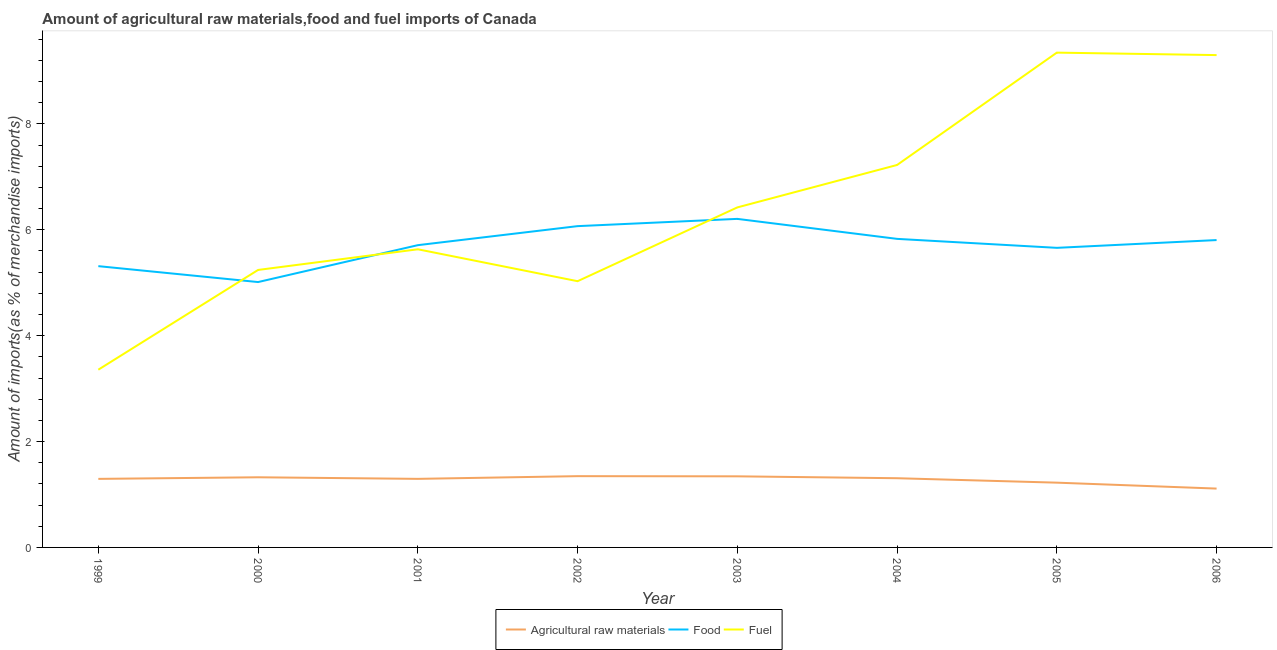How many different coloured lines are there?
Your answer should be very brief. 3. Does the line corresponding to percentage of food imports intersect with the line corresponding to percentage of raw materials imports?
Offer a terse response. No. What is the percentage of fuel imports in 2001?
Your response must be concise. 5.63. Across all years, what is the maximum percentage of fuel imports?
Ensure brevity in your answer.  9.35. Across all years, what is the minimum percentage of fuel imports?
Your answer should be compact. 3.36. In which year was the percentage of raw materials imports maximum?
Your response must be concise. 2002. In which year was the percentage of fuel imports minimum?
Your answer should be compact. 1999. What is the total percentage of food imports in the graph?
Your answer should be compact. 45.6. What is the difference between the percentage of raw materials imports in 2001 and that in 2002?
Offer a terse response. -0.05. What is the difference between the percentage of fuel imports in 2006 and the percentage of raw materials imports in 2003?
Offer a terse response. 7.96. What is the average percentage of food imports per year?
Keep it short and to the point. 5.7. In the year 1999, what is the difference between the percentage of food imports and percentage of fuel imports?
Keep it short and to the point. 1.96. In how many years, is the percentage of food imports greater than 7.6 %?
Your answer should be compact. 0. What is the ratio of the percentage of fuel imports in 2000 to that in 2005?
Keep it short and to the point. 0.56. Is the percentage of raw materials imports in 2001 less than that in 2005?
Ensure brevity in your answer.  No. What is the difference between the highest and the second highest percentage of raw materials imports?
Ensure brevity in your answer.  0. What is the difference between the highest and the lowest percentage of raw materials imports?
Offer a terse response. 0.23. Is it the case that in every year, the sum of the percentage of raw materials imports and percentage of food imports is greater than the percentage of fuel imports?
Your answer should be compact. No. Does the percentage of food imports monotonically increase over the years?
Your answer should be very brief. No. Is the percentage of fuel imports strictly greater than the percentage of raw materials imports over the years?
Your response must be concise. Yes. Is the percentage of raw materials imports strictly less than the percentage of food imports over the years?
Your response must be concise. Yes. How many lines are there?
Give a very brief answer. 3. How many years are there in the graph?
Your response must be concise. 8. Does the graph contain any zero values?
Keep it short and to the point. No. Does the graph contain grids?
Give a very brief answer. No. Where does the legend appear in the graph?
Offer a terse response. Bottom center. How many legend labels are there?
Provide a short and direct response. 3. What is the title of the graph?
Make the answer very short. Amount of agricultural raw materials,food and fuel imports of Canada. What is the label or title of the X-axis?
Give a very brief answer. Year. What is the label or title of the Y-axis?
Provide a short and direct response. Amount of imports(as % of merchandise imports). What is the Amount of imports(as % of merchandise imports) of Agricultural raw materials in 1999?
Keep it short and to the point. 1.29. What is the Amount of imports(as % of merchandise imports) of Food in 1999?
Your answer should be very brief. 5.31. What is the Amount of imports(as % of merchandise imports) in Fuel in 1999?
Provide a succinct answer. 3.36. What is the Amount of imports(as % of merchandise imports) of Agricultural raw materials in 2000?
Your answer should be very brief. 1.33. What is the Amount of imports(as % of merchandise imports) of Food in 2000?
Give a very brief answer. 5.01. What is the Amount of imports(as % of merchandise imports) of Fuel in 2000?
Your answer should be compact. 5.24. What is the Amount of imports(as % of merchandise imports) of Agricultural raw materials in 2001?
Offer a terse response. 1.3. What is the Amount of imports(as % of merchandise imports) of Food in 2001?
Your response must be concise. 5.71. What is the Amount of imports(as % of merchandise imports) of Fuel in 2001?
Keep it short and to the point. 5.63. What is the Amount of imports(as % of merchandise imports) of Agricultural raw materials in 2002?
Your answer should be very brief. 1.35. What is the Amount of imports(as % of merchandise imports) of Food in 2002?
Ensure brevity in your answer.  6.07. What is the Amount of imports(as % of merchandise imports) in Fuel in 2002?
Keep it short and to the point. 5.03. What is the Amount of imports(as % of merchandise imports) of Agricultural raw materials in 2003?
Keep it short and to the point. 1.34. What is the Amount of imports(as % of merchandise imports) in Food in 2003?
Offer a terse response. 6.21. What is the Amount of imports(as % of merchandise imports) of Fuel in 2003?
Your response must be concise. 6.42. What is the Amount of imports(as % of merchandise imports) of Agricultural raw materials in 2004?
Give a very brief answer. 1.31. What is the Amount of imports(as % of merchandise imports) in Food in 2004?
Your response must be concise. 5.83. What is the Amount of imports(as % of merchandise imports) of Fuel in 2004?
Your answer should be very brief. 7.22. What is the Amount of imports(as % of merchandise imports) of Agricultural raw materials in 2005?
Give a very brief answer. 1.22. What is the Amount of imports(as % of merchandise imports) in Food in 2005?
Ensure brevity in your answer.  5.66. What is the Amount of imports(as % of merchandise imports) of Fuel in 2005?
Offer a very short reply. 9.35. What is the Amount of imports(as % of merchandise imports) of Agricultural raw materials in 2006?
Your answer should be compact. 1.11. What is the Amount of imports(as % of merchandise imports) of Food in 2006?
Offer a very short reply. 5.81. What is the Amount of imports(as % of merchandise imports) in Fuel in 2006?
Provide a short and direct response. 9.3. Across all years, what is the maximum Amount of imports(as % of merchandise imports) in Agricultural raw materials?
Your response must be concise. 1.35. Across all years, what is the maximum Amount of imports(as % of merchandise imports) in Food?
Offer a very short reply. 6.21. Across all years, what is the maximum Amount of imports(as % of merchandise imports) in Fuel?
Make the answer very short. 9.35. Across all years, what is the minimum Amount of imports(as % of merchandise imports) in Agricultural raw materials?
Your response must be concise. 1.11. Across all years, what is the minimum Amount of imports(as % of merchandise imports) in Food?
Give a very brief answer. 5.01. Across all years, what is the minimum Amount of imports(as % of merchandise imports) in Fuel?
Make the answer very short. 3.36. What is the total Amount of imports(as % of merchandise imports) in Agricultural raw materials in the graph?
Offer a terse response. 10.25. What is the total Amount of imports(as % of merchandise imports) in Food in the graph?
Your response must be concise. 45.6. What is the total Amount of imports(as % of merchandise imports) in Fuel in the graph?
Provide a short and direct response. 51.55. What is the difference between the Amount of imports(as % of merchandise imports) in Agricultural raw materials in 1999 and that in 2000?
Offer a very short reply. -0.03. What is the difference between the Amount of imports(as % of merchandise imports) in Food in 1999 and that in 2000?
Provide a short and direct response. 0.3. What is the difference between the Amount of imports(as % of merchandise imports) in Fuel in 1999 and that in 2000?
Make the answer very short. -1.88. What is the difference between the Amount of imports(as % of merchandise imports) of Agricultural raw materials in 1999 and that in 2001?
Give a very brief answer. -0. What is the difference between the Amount of imports(as % of merchandise imports) of Food in 1999 and that in 2001?
Make the answer very short. -0.4. What is the difference between the Amount of imports(as % of merchandise imports) of Fuel in 1999 and that in 2001?
Offer a terse response. -2.27. What is the difference between the Amount of imports(as % of merchandise imports) in Agricultural raw materials in 1999 and that in 2002?
Provide a succinct answer. -0.05. What is the difference between the Amount of imports(as % of merchandise imports) of Food in 1999 and that in 2002?
Keep it short and to the point. -0.76. What is the difference between the Amount of imports(as % of merchandise imports) of Fuel in 1999 and that in 2002?
Offer a terse response. -1.67. What is the difference between the Amount of imports(as % of merchandise imports) in Agricultural raw materials in 1999 and that in 2003?
Offer a very short reply. -0.05. What is the difference between the Amount of imports(as % of merchandise imports) of Food in 1999 and that in 2003?
Ensure brevity in your answer.  -0.89. What is the difference between the Amount of imports(as % of merchandise imports) in Fuel in 1999 and that in 2003?
Keep it short and to the point. -3.07. What is the difference between the Amount of imports(as % of merchandise imports) in Agricultural raw materials in 1999 and that in 2004?
Give a very brief answer. -0.01. What is the difference between the Amount of imports(as % of merchandise imports) in Food in 1999 and that in 2004?
Provide a short and direct response. -0.52. What is the difference between the Amount of imports(as % of merchandise imports) of Fuel in 1999 and that in 2004?
Ensure brevity in your answer.  -3.87. What is the difference between the Amount of imports(as % of merchandise imports) of Agricultural raw materials in 1999 and that in 2005?
Offer a terse response. 0.07. What is the difference between the Amount of imports(as % of merchandise imports) of Food in 1999 and that in 2005?
Provide a succinct answer. -0.35. What is the difference between the Amount of imports(as % of merchandise imports) in Fuel in 1999 and that in 2005?
Your response must be concise. -5.99. What is the difference between the Amount of imports(as % of merchandise imports) in Agricultural raw materials in 1999 and that in 2006?
Your answer should be compact. 0.18. What is the difference between the Amount of imports(as % of merchandise imports) of Food in 1999 and that in 2006?
Offer a terse response. -0.49. What is the difference between the Amount of imports(as % of merchandise imports) of Fuel in 1999 and that in 2006?
Give a very brief answer. -5.94. What is the difference between the Amount of imports(as % of merchandise imports) of Agricultural raw materials in 2000 and that in 2001?
Offer a terse response. 0.03. What is the difference between the Amount of imports(as % of merchandise imports) in Food in 2000 and that in 2001?
Your answer should be very brief. -0.7. What is the difference between the Amount of imports(as % of merchandise imports) of Fuel in 2000 and that in 2001?
Provide a short and direct response. -0.39. What is the difference between the Amount of imports(as % of merchandise imports) in Agricultural raw materials in 2000 and that in 2002?
Provide a short and direct response. -0.02. What is the difference between the Amount of imports(as % of merchandise imports) in Food in 2000 and that in 2002?
Ensure brevity in your answer.  -1.06. What is the difference between the Amount of imports(as % of merchandise imports) of Fuel in 2000 and that in 2002?
Give a very brief answer. 0.21. What is the difference between the Amount of imports(as % of merchandise imports) of Agricultural raw materials in 2000 and that in 2003?
Offer a terse response. -0.02. What is the difference between the Amount of imports(as % of merchandise imports) of Food in 2000 and that in 2003?
Give a very brief answer. -1.19. What is the difference between the Amount of imports(as % of merchandise imports) in Fuel in 2000 and that in 2003?
Your response must be concise. -1.18. What is the difference between the Amount of imports(as % of merchandise imports) of Agricultural raw materials in 2000 and that in 2004?
Provide a short and direct response. 0.02. What is the difference between the Amount of imports(as % of merchandise imports) of Food in 2000 and that in 2004?
Make the answer very short. -0.82. What is the difference between the Amount of imports(as % of merchandise imports) of Fuel in 2000 and that in 2004?
Make the answer very short. -1.98. What is the difference between the Amount of imports(as % of merchandise imports) in Agricultural raw materials in 2000 and that in 2005?
Offer a very short reply. 0.1. What is the difference between the Amount of imports(as % of merchandise imports) in Food in 2000 and that in 2005?
Your answer should be compact. -0.65. What is the difference between the Amount of imports(as % of merchandise imports) of Fuel in 2000 and that in 2005?
Offer a terse response. -4.11. What is the difference between the Amount of imports(as % of merchandise imports) of Agricultural raw materials in 2000 and that in 2006?
Your answer should be very brief. 0.21. What is the difference between the Amount of imports(as % of merchandise imports) in Food in 2000 and that in 2006?
Provide a succinct answer. -0.79. What is the difference between the Amount of imports(as % of merchandise imports) of Fuel in 2000 and that in 2006?
Your answer should be compact. -4.06. What is the difference between the Amount of imports(as % of merchandise imports) of Agricultural raw materials in 2001 and that in 2002?
Provide a short and direct response. -0.05. What is the difference between the Amount of imports(as % of merchandise imports) of Food in 2001 and that in 2002?
Offer a very short reply. -0.36. What is the difference between the Amount of imports(as % of merchandise imports) in Fuel in 2001 and that in 2002?
Make the answer very short. 0.6. What is the difference between the Amount of imports(as % of merchandise imports) of Agricultural raw materials in 2001 and that in 2003?
Ensure brevity in your answer.  -0.05. What is the difference between the Amount of imports(as % of merchandise imports) of Food in 2001 and that in 2003?
Your response must be concise. -0.5. What is the difference between the Amount of imports(as % of merchandise imports) in Fuel in 2001 and that in 2003?
Your answer should be compact. -0.79. What is the difference between the Amount of imports(as % of merchandise imports) of Agricultural raw materials in 2001 and that in 2004?
Your response must be concise. -0.01. What is the difference between the Amount of imports(as % of merchandise imports) in Food in 2001 and that in 2004?
Provide a short and direct response. -0.12. What is the difference between the Amount of imports(as % of merchandise imports) in Fuel in 2001 and that in 2004?
Give a very brief answer. -1.59. What is the difference between the Amount of imports(as % of merchandise imports) of Agricultural raw materials in 2001 and that in 2005?
Your answer should be very brief. 0.07. What is the difference between the Amount of imports(as % of merchandise imports) of Food in 2001 and that in 2005?
Provide a short and direct response. 0.05. What is the difference between the Amount of imports(as % of merchandise imports) in Fuel in 2001 and that in 2005?
Your answer should be compact. -3.71. What is the difference between the Amount of imports(as % of merchandise imports) of Agricultural raw materials in 2001 and that in 2006?
Make the answer very short. 0.18. What is the difference between the Amount of imports(as % of merchandise imports) of Food in 2001 and that in 2006?
Your response must be concise. -0.1. What is the difference between the Amount of imports(as % of merchandise imports) of Fuel in 2001 and that in 2006?
Your answer should be very brief. -3.67. What is the difference between the Amount of imports(as % of merchandise imports) in Agricultural raw materials in 2002 and that in 2003?
Offer a terse response. 0. What is the difference between the Amount of imports(as % of merchandise imports) of Food in 2002 and that in 2003?
Your answer should be compact. -0.14. What is the difference between the Amount of imports(as % of merchandise imports) in Fuel in 2002 and that in 2003?
Offer a terse response. -1.39. What is the difference between the Amount of imports(as % of merchandise imports) of Agricultural raw materials in 2002 and that in 2004?
Offer a very short reply. 0.04. What is the difference between the Amount of imports(as % of merchandise imports) of Food in 2002 and that in 2004?
Provide a short and direct response. 0.24. What is the difference between the Amount of imports(as % of merchandise imports) of Fuel in 2002 and that in 2004?
Keep it short and to the point. -2.2. What is the difference between the Amount of imports(as % of merchandise imports) of Agricultural raw materials in 2002 and that in 2005?
Keep it short and to the point. 0.12. What is the difference between the Amount of imports(as % of merchandise imports) of Food in 2002 and that in 2005?
Your answer should be compact. 0.41. What is the difference between the Amount of imports(as % of merchandise imports) of Fuel in 2002 and that in 2005?
Your answer should be compact. -4.32. What is the difference between the Amount of imports(as % of merchandise imports) of Agricultural raw materials in 2002 and that in 2006?
Your response must be concise. 0.23. What is the difference between the Amount of imports(as % of merchandise imports) in Food in 2002 and that in 2006?
Keep it short and to the point. 0.26. What is the difference between the Amount of imports(as % of merchandise imports) of Fuel in 2002 and that in 2006?
Provide a succinct answer. -4.27. What is the difference between the Amount of imports(as % of merchandise imports) of Agricultural raw materials in 2003 and that in 2004?
Provide a short and direct response. 0.04. What is the difference between the Amount of imports(as % of merchandise imports) in Food in 2003 and that in 2004?
Ensure brevity in your answer.  0.38. What is the difference between the Amount of imports(as % of merchandise imports) in Fuel in 2003 and that in 2004?
Your response must be concise. -0.8. What is the difference between the Amount of imports(as % of merchandise imports) of Agricultural raw materials in 2003 and that in 2005?
Provide a short and direct response. 0.12. What is the difference between the Amount of imports(as % of merchandise imports) in Food in 2003 and that in 2005?
Keep it short and to the point. 0.55. What is the difference between the Amount of imports(as % of merchandise imports) in Fuel in 2003 and that in 2005?
Your response must be concise. -2.92. What is the difference between the Amount of imports(as % of merchandise imports) of Agricultural raw materials in 2003 and that in 2006?
Provide a succinct answer. 0.23. What is the difference between the Amount of imports(as % of merchandise imports) in Food in 2003 and that in 2006?
Give a very brief answer. 0.4. What is the difference between the Amount of imports(as % of merchandise imports) in Fuel in 2003 and that in 2006?
Give a very brief answer. -2.88. What is the difference between the Amount of imports(as % of merchandise imports) of Agricultural raw materials in 2004 and that in 2005?
Offer a very short reply. 0.08. What is the difference between the Amount of imports(as % of merchandise imports) in Food in 2004 and that in 2005?
Make the answer very short. 0.17. What is the difference between the Amount of imports(as % of merchandise imports) of Fuel in 2004 and that in 2005?
Keep it short and to the point. -2.12. What is the difference between the Amount of imports(as % of merchandise imports) of Agricultural raw materials in 2004 and that in 2006?
Offer a terse response. 0.2. What is the difference between the Amount of imports(as % of merchandise imports) in Food in 2004 and that in 2006?
Provide a short and direct response. 0.02. What is the difference between the Amount of imports(as % of merchandise imports) of Fuel in 2004 and that in 2006?
Your answer should be very brief. -2.08. What is the difference between the Amount of imports(as % of merchandise imports) in Agricultural raw materials in 2005 and that in 2006?
Give a very brief answer. 0.11. What is the difference between the Amount of imports(as % of merchandise imports) of Food in 2005 and that in 2006?
Provide a short and direct response. -0.15. What is the difference between the Amount of imports(as % of merchandise imports) of Fuel in 2005 and that in 2006?
Your answer should be compact. 0.05. What is the difference between the Amount of imports(as % of merchandise imports) in Agricultural raw materials in 1999 and the Amount of imports(as % of merchandise imports) in Food in 2000?
Your answer should be very brief. -3.72. What is the difference between the Amount of imports(as % of merchandise imports) of Agricultural raw materials in 1999 and the Amount of imports(as % of merchandise imports) of Fuel in 2000?
Your answer should be very brief. -3.95. What is the difference between the Amount of imports(as % of merchandise imports) in Food in 1999 and the Amount of imports(as % of merchandise imports) in Fuel in 2000?
Your answer should be compact. 0.07. What is the difference between the Amount of imports(as % of merchandise imports) of Agricultural raw materials in 1999 and the Amount of imports(as % of merchandise imports) of Food in 2001?
Provide a short and direct response. -4.41. What is the difference between the Amount of imports(as % of merchandise imports) of Agricultural raw materials in 1999 and the Amount of imports(as % of merchandise imports) of Fuel in 2001?
Give a very brief answer. -4.34. What is the difference between the Amount of imports(as % of merchandise imports) in Food in 1999 and the Amount of imports(as % of merchandise imports) in Fuel in 2001?
Offer a very short reply. -0.32. What is the difference between the Amount of imports(as % of merchandise imports) in Agricultural raw materials in 1999 and the Amount of imports(as % of merchandise imports) in Food in 2002?
Your response must be concise. -4.77. What is the difference between the Amount of imports(as % of merchandise imports) in Agricultural raw materials in 1999 and the Amount of imports(as % of merchandise imports) in Fuel in 2002?
Offer a very short reply. -3.73. What is the difference between the Amount of imports(as % of merchandise imports) in Food in 1999 and the Amount of imports(as % of merchandise imports) in Fuel in 2002?
Provide a succinct answer. 0.28. What is the difference between the Amount of imports(as % of merchandise imports) in Agricultural raw materials in 1999 and the Amount of imports(as % of merchandise imports) in Food in 2003?
Ensure brevity in your answer.  -4.91. What is the difference between the Amount of imports(as % of merchandise imports) in Agricultural raw materials in 1999 and the Amount of imports(as % of merchandise imports) in Fuel in 2003?
Your response must be concise. -5.13. What is the difference between the Amount of imports(as % of merchandise imports) of Food in 1999 and the Amount of imports(as % of merchandise imports) of Fuel in 2003?
Your response must be concise. -1.11. What is the difference between the Amount of imports(as % of merchandise imports) in Agricultural raw materials in 1999 and the Amount of imports(as % of merchandise imports) in Food in 2004?
Your response must be concise. -4.53. What is the difference between the Amount of imports(as % of merchandise imports) of Agricultural raw materials in 1999 and the Amount of imports(as % of merchandise imports) of Fuel in 2004?
Offer a very short reply. -5.93. What is the difference between the Amount of imports(as % of merchandise imports) of Food in 1999 and the Amount of imports(as % of merchandise imports) of Fuel in 2004?
Give a very brief answer. -1.91. What is the difference between the Amount of imports(as % of merchandise imports) of Agricultural raw materials in 1999 and the Amount of imports(as % of merchandise imports) of Food in 2005?
Offer a terse response. -4.36. What is the difference between the Amount of imports(as % of merchandise imports) in Agricultural raw materials in 1999 and the Amount of imports(as % of merchandise imports) in Fuel in 2005?
Provide a short and direct response. -8.05. What is the difference between the Amount of imports(as % of merchandise imports) in Food in 1999 and the Amount of imports(as % of merchandise imports) in Fuel in 2005?
Make the answer very short. -4.03. What is the difference between the Amount of imports(as % of merchandise imports) in Agricultural raw materials in 1999 and the Amount of imports(as % of merchandise imports) in Food in 2006?
Keep it short and to the point. -4.51. What is the difference between the Amount of imports(as % of merchandise imports) of Agricultural raw materials in 1999 and the Amount of imports(as % of merchandise imports) of Fuel in 2006?
Your answer should be compact. -8.01. What is the difference between the Amount of imports(as % of merchandise imports) in Food in 1999 and the Amount of imports(as % of merchandise imports) in Fuel in 2006?
Give a very brief answer. -3.99. What is the difference between the Amount of imports(as % of merchandise imports) in Agricultural raw materials in 2000 and the Amount of imports(as % of merchandise imports) in Food in 2001?
Provide a succinct answer. -4.38. What is the difference between the Amount of imports(as % of merchandise imports) of Agricultural raw materials in 2000 and the Amount of imports(as % of merchandise imports) of Fuel in 2001?
Provide a succinct answer. -4.31. What is the difference between the Amount of imports(as % of merchandise imports) in Food in 2000 and the Amount of imports(as % of merchandise imports) in Fuel in 2001?
Give a very brief answer. -0.62. What is the difference between the Amount of imports(as % of merchandise imports) in Agricultural raw materials in 2000 and the Amount of imports(as % of merchandise imports) in Food in 2002?
Offer a very short reply. -4.74. What is the difference between the Amount of imports(as % of merchandise imports) of Agricultural raw materials in 2000 and the Amount of imports(as % of merchandise imports) of Fuel in 2002?
Keep it short and to the point. -3.7. What is the difference between the Amount of imports(as % of merchandise imports) of Food in 2000 and the Amount of imports(as % of merchandise imports) of Fuel in 2002?
Provide a succinct answer. -0.02. What is the difference between the Amount of imports(as % of merchandise imports) of Agricultural raw materials in 2000 and the Amount of imports(as % of merchandise imports) of Food in 2003?
Your answer should be very brief. -4.88. What is the difference between the Amount of imports(as % of merchandise imports) in Agricultural raw materials in 2000 and the Amount of imports(as % of merchandise imports) in Fuel in 2003?
Ensure brevity in your answer.  -5.1. What is the difference between the Amount of imports(as % of merchandise imports) in Food in 2000 and the Amount of imports(as % of merchandise imports) in Fuel in 2003?
Give a very brief answer. -1.41. What is the difference between the Amount of imports(as % of merchandise imports) of Agricultural raw materials in 2000 and the Amount of imports(as % of merchandise imports) of Food in 2004?
Your answer should be compact. -4.5. What is the difference between the Amount of imports(as % of merchandise imports) of Agricultural raw materials in 2000 and the Amount of imports(as % of merchandise imports) of Fuel in 2004?
Your answer should be very brief. -5.9. What is the difference between the Amount of imports(as % of merchandise imports) in Food in 2000 and the Amount of imports(as % of merchandise imports) in Fuel in 2004?
Make the answer very short. -2.21. What is the difference between the Amount of imports(as % of merchandise imports) in Agricultural raw materials in 2000 and the Amount of imports(as % of merchandise imports) in Food in 2005?
Give a very brief answer. -4.33. What is the difference between the Amount of imports(as % of merchandise imports) in Agricultural raw materials in 2000 and the Amount of imports(as % of merchandise imports) in Fuel in 2005?
Offer a terse response. -8.02. What is the difference between the Amount of imports(as % of merchandise imports) in Food in 2000 and the Amount of imports(as % of merchandise imports) in Fuel in 2005?
Offer a very short reply. -4.33. What is the difference between the Amount of imports(as % of merchandise imports) in Agricultural raw materials in 2000 and the Amount of imports(as % of merchandise imports) in Food in 2006?
Your answer should be compact. -4.48. What is the difference between the Amount of imports(as % of merchandise imports) of Agricultural raw materials in 2000 and the Amount of imports(as % of merchandise imports) of Fuel in 2006?
Make the answer very short. -7.97. What is the difference between the Amount of imports(as % of merchandise imports) of Food in 2000 and the Amount of imports(as % of merchandise imports) of Fuel in 2006?
Keep it short and to the point. -4.29. What is the difference between the Amount of imports(as % of merchandise imports) in Agricultural raw materials in 2001 and the Amount of imports(as % of merchandise imports) in Food in 2002?
Provide a short and direct response. -4.77. What is the difference between the Amount of imports(as % of merchandise imports) in Agricultural raw materials in 2001 and the Amount of imports(as % of merchandise imports) in Fuel in 2002?
Make the answer very short. -3.73. What is the difference between the Amount of imports(as % of merchandise imports) in Food in 2001 and the Amount of imports(as % of merchandise imports) in Fuel in 2002?
Keep it short and to the point. 0.68. What is the difference between the Amount of imports(as % of merchandise imports) in Agricultural raw materials in 2001 and the Amount of imports(as % of merchandise imports) in Food in 2003?
Make the answer very short. -4.91. What is the difference between the Amount of imports(as % of merchandise imports) in Agricultural raw materials in 2001 and the Amount of imports(as % of merchandise imports) in Fuel in 2003?
Make the answer very short. -5.13. What is the difference between the Amount of imports(as % of merchandise imports) in Food in 2001 and the Amount of imports(as % of merchandise imports) in Fuel in 2003?
Give a very brief answer. -0.71. What is the difference between the Amount of imports(as % of merchandise imports) of Agricultural raw materials in 2001 and the Amount of imports(as % of merchandise imports) of Food in 2004?
Offer a terse response. -4.53. What is the difference between the Amount of imports(as % of merchandise imports) of Agricultural raw materials in 2001 and the Amount of imports(as % of merchandise imports) of Fuel in 2004?
Keep it short and to the point. -5.93. What is the difference between the Amount of imports(as % of merchandise imports) of Food in 2001 and the Amount of imports(as % of merchandise imports) of Fuel in 2004?
Provide a short and direct response. -1.51. What is the difference between the Amount of imports(as % of merchandise imports) in Agricultural raw materials in 2001 and the Amount of imports(as % of merchandise imports) in Food in 2005?
Your answer should be compact. -4.36. What is the difference between the Amount of imports(as % of merchandise imports) in Agricultural raw materials in 2001 and the Amount of imports(as % of merchandise imports) in Fuel in 2005?
Give a very brief answer. -8.05. What is the difference between the Amount of imports(as % of merchandise imports) in Food in 2001 and the Amount of imports(as % of merchandise imports) in Fuel in 2005?
Your answer should be compact. -3.64. What is the difference between the Amount of imports(as % of merchandise imports) of Agricultural raw materials in 2001 and the Amount of imports(as % of merchandise imports) of Food in 2006?
Give a very brief answer. -4.51. What is the difference between the Amount of imports(as % of merchandise imports) of Agricultural raw materials in 2001 and the Amount of imports(as % of merchandise imports) of Fuel in 2006?
Your answer should be compact. -8. What is the difference between the Amount of imports(as % of merchandise imports) of Food in 2001 and the Amount of imports(as % of merchandise imports) of Fuel in 2006?
Your response must be concise. -3.59. What is the difference between the Amount of imports(as % of merchandise imports) in Agricultural raw materials in 2002 and the Amount of imports(as % of merchandise imports) in Food in 2003?
Your answer should be compact. -4.86. What is the difference between the Amount of imports(as % of merchandise imports) in Agricultural raw materials in 2002 and the Amount of imports(as % of merchandise imports) in Fuel in 2003?
Offer a very short reply. -5.08. What is the difference between the Amount of imports(as % of merchandise imports) of Food in 2002 and the Amount of imports(as % of merchandise imports) of Fuel in 2003?
Keep it short and to the point. -0.35. What is the difference between the Amount of imports(as % of merchandise imports) in Agricultural raw materials in 2002 and the Amount of imports(as % of merchandise imports) in Food in 2004?
Provide a short and direct response. -4.48. What is the difference between the Amount of imports(as % of merchandise imports) of Agricultural raw materials in 2002 and the Amount of imports(as % of merchandise imports) of Fuel in 2004?
Offer a very short reply. -5.88. What is the difference between the Amount of imports(as % of merchandise imports) in Food in 2002 and the Amount of imports(as % of merchandise imports) in Fuel in 2004?
Offer a terse response. -1.16. What is the difference between the Amount of imports(as % of merchandise imports) in Agricultural raw materials in 2002 and the Amount of imports(as % of merchandise imports) in Food in 2005?
Offer a terse response. -4.31. What is the difference between the Amount of imports(as % of merchandise imports) in Agricultural raw materials in 2002 and the Amount of imports(as % of merchandise imports) in Fuel in 2005?
Offer a terse response. -8. What is the difference between the Amount of imports(as % of merchandise imports) of Food in 2002 and the Amount of imports(as % of merchandise imports) of Fuel in 2005?
Give a very brief answer. -3.28. What is the difference between the Amount of imports(as % of merchandise imports) of Agricultural raw materials in 2002 and the Amount of imports(as % of merchandise imports) of Food in 2006?
Your response must be concise. -4.46. What is the difference between the Amount of imports(as % of merchandise imports) in Agricultural raw materials in 2002 and the Amount of imports(as % of merchandise imports) in Fuel in 2006?
Provide a succinct answer. -7.95. What is the difference between the Amount of imports(as % of merchandise imports) in Food in 2002 and the Amount of imports(as % of merchandise imports) in Fuel in 2006?
Give a very brief answer. -3.23. What is the difference between the Amount of imports(as % of merchandise imports) in Agricultural raw materials in 2003 and the Amount of imports(as % of merchandise imports) in Food in 2004?
Provide a short and direct response. -4.49. What is the difference between the Amount of imports(as % of merchandise imports) of Agricultural raw materials in 2003 and the Amount of imports(as % of merchandise imports) of Fuel in 2004?
Provide a short and direct response. -5.88. What is the difference between the Amount of imports(as % of merchandise imports) of Food in 2003 and the Amount of imports(as % of merchandise imports) of Fuel in 2004?
Your answer should be very brief. -1.02. What is the difference between the Amount of imports(as % of merchandise imports) in Agricultural raw materials in 2003 and the Amount of imports(as % of merchandise imports) in Food in 2005?
Provide a short and direct response. -4.32. What is the difference between the Amount of imports(as % of merchandise imports) of Agricultural raw materials in 2003 and the Amount of imports(as % of merchandise imports) of Fuel in 2005?
Give a very brief answer. -8. What is the difference between the Amount of imports(as % of merchandise imports) of Food in 2003 and the Amount of imports(as % of merchandise imports) of Fuel in 2005?
Your answer should be very brief. -3.14. What is the difference between the Amount of imports(as % of merchandise imports) in Agricultural raw materials in 2003 and the Amount of imports(as % of merchandise imports) in Food in 2006?
Your answer should be compact. -4.46. What is the difference between the Amount of imports(as % of merchandise imports) of Agricultural raw materials in 2003 and the Amount of imports(as % of merchandise imports) of Fuel in 2006?
Your answer should be compact. -7.96. What is the difference between the Amount of imports(as % of merchandise imports) of Food in 2003 and the Amount of imports(as % of merchandise imports) of Fuel in 2006?
Make the answer very short. -3.09. What is the difference between the Amount of imports(as % of merchandise imports) of Agricultural raw materials in 2004 and the Amount of imports(as % of merchandise imports) of Food in 2005?
Your answer should be very brief. -4.35. What is the difference between the Amount of imports(as % of merchandise imports) of Agricultural raw materials in 2004 and the Amount of imports(as % of merchandise imports) of Fuel in 2005?
Give a very brief answer. -8.04. What is the difference between the Amount of imports(as % of merchandise imports) of Food in 2004 and the Amount of imports(as % of merchandise imports) of Fuel in 2005?
Give a very brief answer. -3.52. What is the difference between the Amount of imports(as % of merchandise imports) of Agricultural raw materials in 2004 and the Amount of imports(as % of merchandise imports) of Food in 2006?
Your answer should be very brief. -4.5. What is the difference between the Amount of imports(as % of merchandise imports) of Agricultural raw materials in 2004 and the Amount of imports(as % of merchandise imports) of Fuel in 2006?
Make the answer very short. -7.99. What is the difference between the Amount of imports(as % of merchandise imports) of Food in 2004 and the Amount of imports(as % of merchandise imports) of Fuel in 2006?
Provide a short and direct response. -3.47. What is the difference between the Amount of imports(as % of merchandise imports) of Agricultural raw materials in 2005 and the Amount of imports(as % of merchandise imports) of Food in 2006?
Your answer should be compact. -4.58. What is the difference between the Amount of imports(as % of merchandise imports) in Agricultural raw materials in 2005 and the Amount of imports(as % of merchandise imports) in Fuel in 2006?
Provide a short and direct response. -8.08. What is the difference between the Amount of imports(as % of merchandise imports) of Food in 2005 and the Amount of imports(as % of merchandise imports) of Fuel in 2006?
Offer a very short reply. -3.64. What is the average Amount of imports(as % of merchandise imports) of Agricultural raw materials per year?
Offer a very short reply. 1.28. What is the average Amount of imports(as % of merchandise imports) in Food per year?
Your answer should be very brief. 5.7. What is the average Amount of imports(as % of merchandise imports) of Fuel per year?
Your response must be concise. 6.44. In the year 1999, what is the difference between the Amount of imports(as % of merchandise imports) in Agricultural raw materials and Amount of imports(as % of merchandise imports) in Food?
Give a very brief answer. -4.02. In the year 1999, what is the difference between the Amount of imports(as % of merchandise imports) in Agricultural raw materials and Amount of imports(as % of merchandise imports) in Fuel?
Give a very brief answer. -2.06. In the year 1999, what is the difference between the Amount of imports(as % of merchandise imports) in Food and Amount of imports(as % of merchandise imports) in Fuel?
Your response must be concise. 1.96. In the year 2000, what is the difference between the Amount of imports(as % of merchandise imports) of Agricultural raw materials and Amount of imports(as % of merchandise imports) of Food?
Offer a terse response. -3.69. In the year 2000, what is the difference between the Amount of imports(as % of merchandise imports) of Agricultural raw materials and Amount of imports(as % of merchandise imports) of Fuel?
Offer a very short reply. -3.92. In the year 2000, what is the difference between the Amount of imports(as % of merchandise imports) in Food and Amount of imports(as % of merchandise imports) in Fuel?
Your answer should be very brief. -0.23. In the year 2001, what is the difference between the Amount of imports(as % of merchandise imports) in Agricultural raw materials and Amount of imports(as % of merchandise imports) in Food?
Ensure brevity in your answer.  -4.41. In the year 2001, what is the difference between the Amount of imports(as % of merchandise imports) of Agricultural raw materials and Amount of imports(as % of merchandise imports) of Fuel?
Provide a succinct answer. -4.34. In the year 2001, what is the difference between the Amount of imports(as % of merchandise imports) of Food and Amount of imports(as % of merchandise imports) of Fuel?
Your response must be concise. 0.08. In the year 2002, what is the difference between the Amount of imports(as % of merchandise imports) in Agricultural raw materials and Amount of imports(as % of merchandise imports) in Food?
Provide a short and direct response. -4.72. In the year 2002, what is the difference between the Amount of imports(as % of merchandise imports) in Agricultural raw materials and Amount of imports(as % of merchandise imports) in Fuel?
Offer a terse response. -3.68. In the year 2002, what is the difference between the Amount of imports(as % of merchandise imports) in Food and Amount of imports(as % of merchandise imports) in Fuel?
Give a very brief answer. 1.04. In the year 2003, what is the difference between the Amount of imports(as % of merchandise imports) in Agricultural raw materials and Amount of imports(as % of merchandise imports) in Food?
Offer a terse response. -4.86. In the year 2003, what is the difference between the Amount of imports(as % of merchandise imports) in Agricultural raw materials and Amount of imports(as % of merchandise imports) in Fuel?
Your answer should be compact. -5.08. In the year 2003, what is the difference between the Amount of imports(as % of merchandise imports) in Food and Amount of imports(as % of merchandise imports) in Fuel?
Keep it short and to the point. -0.22. In the year 2004, what is the difference between the Amount of imports(as % of merchandise imports) in Agricultural raw materials and Amount of imports(as % of merchandise imports) in Food?
Offer a terse response. -4.52. In the year 2004, what is the difference between the Amount of imports(as % of merchandise imports) of Agricultural raw materials and Amount of imports(as % of merchandise imports) of Fuel?
Keep it short and to the point. -5.92. In the year 2004, what is the difference between the Amount of imports(as % of merchandise imports) in Food and Amount of imports(as % of merchandise imports) in Fuel?
Offer a terse response. -1.4. In the year 2005, what is the difference between the Amount of imports(as % of merchandise imports) in Agricultural raw materials and Amount of imports(as % of merchandise imports) in Food?
Make the answer very short. -4.44. In the year 2005, what is the difference between the Amount of imports(as % of merchandise imports) of Agricultural raw materials and Amount of imports(as % of merchandise imports) of Fuel?
Offer a terse response. -8.12. In the year 2005, what is the difference between the Amount of imports(as % of merchandise imports) in Food and Amount of imports(as % of merchandise imports) in Fuel?
Provide a short and direct response. -3.69. In the year 2006, what is the difference between the Amount of imports(as % of merchandise imports) of Agricultural raw materials and Amount of imports(as % of merchandise imports) of Food?
Provide a succinct answer. -4.69. In the year 2006, what is the difference between the Amount of imports(as % of merchandise imports) of Agricultural raw materials and Amount of imports(as % of merchandise imports) of Fuel?
Offer a terse response. -8.19. In the year 2006, what is the difference between the Amount of imports(as % of merchandise imports) of Food and Amount of imports(as % of merchandise imports) of Fuel?
Your answer should be very brief. -3.49. What is the ratio of the Amount of imports(as % of merchandise imports) of Agricultural raw materials in 1999 to that in 2000?
Ensure brevity in your answer.  0.98. What is the ratio of the Amount of imports(as % of merchandise imports) in Food in 1999 to that in 2000?
Provide a succinct answer. 1.06. What is the ratio of the Amount of imports(as % of merchandise imports) in Fuel in 1999 to that in 2000?
Keep it short and to the point. 0.64. What is the ratio of the Amount of imports(as % of merchandise imports) of Agricultural raw materials in 1999 to that in 2001?
Offer a very short reply. 1. What is the ratio of the Amount of imports(as % of merchandise imports) of Food in 1999 to that in 2001?
Provide a short and direct response. 0.93. What is the ratio of the Amount of imports(as % of merchandise imports) of Fuel in 1999 to that in 2001?
Make the answer very short. 0.6. What is the ratio of the Amount of imports(as % of merchandise imports) of Agricultural raw materials in 1999 to that in 2002?
Your answer should be very brief. 0.96. What is the ratio of the Amount of imports(as % of merchandise imports) of Food in 1999 to that in 2002?
Offer a terse response. 0.88. What is the ratio of the Amount of imports(as % of merchandise imports) of Fuel in 1999 to that in 2002?
Your response must be concise. 0.67. What is the ratio of the Amount of imports(as % of merchandise imports) in Agricultural raw materials in 1999 to that in 2003?
Give a very brief answer. 0.96. What is the ratio of the Amount of imports(as % of merchandise imports) in Food in 1999 to that in 2003?
Ensure brevity in your answer.  0.86. What is the ratio of the Amount of imports(as % of merchandise imports) in Fuel in 1999 to that in 2003?
Offer a terse response. 0.52. What is the ratio of the Amount of imports(as % of merchandise imports) of Agricultural raw materials in 1999 to that in 2004?
Your answer should be compact. 0.99. What is the ratio of the Amount of imports(as % of merchandise imports) of Food in 1999 to that in 2004?
Keep it short and to the point. 0.91. What is the ratio of the Amount of imports(as % of merchandise imports) of Fuel in 1999 to that in 2004?
Offer a very short reply. 0.46. What is the ratio of the Amount of imports(as % of merchandise imports) of Agricultural raw materials in 1999 to that in 2005?
Ensure brevity in your answer.  1.06. What is the ratio of the Amount of imports(as % of merchandise imports) in Food in 1999 to that in 2005?
Provide a succinct answer. 0.94. What is the ratio of the Amount of imports(as % of merchandise imports) of Fuel in 1999 to that in 2005?
Offer a very short reply. 0.36. What is the ratio of the Amount of imports(as % of merchandise imports) in Agricultural raw materials in 1999 to that in 2006?
Offer a very short reply. 1.16. What is the ratio of the Amount of imports(as % of merchandise imports) in Food in 1999 to that in 2006?
Keep it short and to the point. 0.92. What is the ratio of the Amount of imports(as % of merchandise imports) in Fuel in 1999 to that in 2006?
Your answer should be very brief. 0.36. What is the ratio of the Amount of imports(as % of merchandise imports) of Agricultural raw materials in 2000 to that in 2001?
Ensure brevity in your answer.  1.02. What is the ratio of the Amount of imports(as % of merchandise imports) in Food in 2000 to that in 2001?
Give a very brief answer. 0.88. What is the ratio of the Amount of imports(as % of merchandise imports) of Fuel in 2000 to that in 2001?
Provide a succinct answer. 0.93. What is the ratio of the Amount of imports(as % of merchandise imports) of Agricultural raw materials in 2000 to that in 2002?
Provide a short and direct response. 0.98. What is the ratio of the Amount of imports(as % of merchandise imports) of Food in 2000 to that in 2002?
Provide a short and direct response. 0.83. What is the ratio of the Amount of imports(as % of merchandise imports) in Fuel in 2000 to that in 2002?
Keep it short and to the point. 1.04. What is the ratio of the Amount of imports(as % of merchandise imports) in Agricultural raw materials in 2000 to that in 2003?
Your answer should be compact. 0.99. What is the ratio of the Amount of imports(as % of merchandise imports) in Food in 2000 to that in 2003?
Provide a short and direct response. 0.81. What is the ratio of the Amount of imports(as % of merchandise imports) in Fuel in 2000 to that in 2003?
Make the answer very short. 0.82. What is the ratio of the Amount of imports(as % of merchandise imports) of Agricultural raw materials in 2000 to that in 2004?
Your response must be concise. 1.01. What is the ratio of the Amount of imports(as % of merchandise imports) of Food in 2000 to that in 2004?
Your answer should be compact. 0.86. What is the ratio of the Amount of imports(as % of merchandise imports) of Fuel in 2000 to that in 2004?
Your answer should be very brief. 0.73. What is the ratio of the Amount of imports(as % of merchandise imports) in Agricultural raw materials in 2000 to that in 2005?
Make the answer very short. 1.08. What is the ratio of the Amount of imports(as % of merchandise imports) of Food in 2000 to that in 2005?
Offer a terse response. 0.89. What is the ratio of the Amount of imports(as % of merchandise imports) of Fuel in 2000 to that in 2005?
Give a very brief answer. 0.56. What is the ratio of the Amount of imports(as % of merchandise imports) of Agricultural raw materials in 2000 to that in 2006?
Your response must be concise. 1.19. What is the ratio of the Amount of imports(as % of merchandise imports) in Food in 2000 to that in 2006?
Your answer should be compact. 0.86. What is the ratio of the Amount of imports(as % of merchandise imports) of Fuel in 2000 to that in 2006?
Make the answer very short. 0.56. What is the ratio of the Amount of imports(as % of merchandise imports) of Agricultural raw materials in 2001 to that in 2002?
Provide a succinct answer. 0.96. What is the ratio of the Amount of imports(as % of merchandise imports) in Food in 2001 to that in 2002?
Ensure brevity in your answer.  0.94. What is the ratio of the Amount of imports(as % of merchandise imports) of Fuel in 2001 to that in 2002?
Ensure brevity in your answer.  1.12. What is the ratio of the Amount of imports(as % of merchandise imports) in Agricultural raw materials in 2001 to that in 2003?
Your response must be concise. 0.96. What is the ratio of the Amount of imports(as % of merchandise imports) in Fuel in 2001 to that in 2003?
Give a very brief answer. 0.88. What is the ratio of the Amount of imports(as % of merchandise imports) of Agricultural raw materials in 2001 to that in 2004?
Keep it short and to the point. 0.99. What is the ratio of the Amount of imports(as % of merchandise imports) in Food in 2001 to that in 2004?
Your response must be concise. 0.98. What is the ratio of the Amount of imports(as % of merchandise imports) in Fuel in 2001 to that in 2004?
Ensure brevity in your answer.  0.78. What is the ratio of the Amount of imports(as % of merchandise imports) in Agricultural raw materials in 2001 to that in 2005?
Your answer should be very brief. 1.06. What is the ratio of the Amount of imports(as % of merchandise imports) in Food in 2001 to that in 2005?
Provide a short and direct response. 1.01. What is the ratio of the Amount of imports(as % of merchandise imports) of Fuel in 2001 to that in 2005?
Offer a very short reply. 0.6. What is the ratio of the Amount of imports(as % of merchandise imports) in Agricultural raw materials in 2001 to that in 2006?
Offer a terse response. 1.17. What is the ratio of the Amount of imports(as % of merchandise imports) of Food in 2001 to that in 2006?
Keep it short and to the point. 0.98. What is the ratio of the Amount of imports(as % of merchandise imports) in Fuel in 2001 to that in 2006?
Keep it short and to the point. 0.61. What is the ratio of the Amount of imports(as % of merchandise imports) in Agricultural raw materials in 2002 to that in 2003?
Your response must be concise. 1. What is the ratio of the Amount of imports(as % of merchandise imports) of Food in 2002 to that in 2003?
Your response must be concise. 0.98. What is the ratio of the Amount of imports(as % of merchandise imports) in Fuel in 2002 to that in 2003?
Your answer should be very brief. 0.78. What is the ratio of the Amount of imports(as % of merchandise imports) of Agricultural raw materials in 2002 to that in 2004?
Give a very brief answer. 1.03. What is the ratio of the Amount of imports(as % of merchandise imports) in Food in 2002 to that in 2004?
Offer a terse response. 1.04. What is the ratio of the Amount of imports(as % of merchandise imports) of Fuel in 2002 to that in 2004?
Offer a terse response. 0.7. What is the ratio of the Amount of imports(as % of merchandise imports) of Agricultural raw materials in 2002 to that in 2005?
Provide a succinct answer. 1.1. What is the ratio of the Amount of imports(as % of merchandise imports) of Food in 2002 to that in 2005?
Your answer should be compact. 1.07. What is the ratio of the Amount of imports(as % of merchandise imports) in Fuel in 2002 to that in 2005?
Provide a short and direct response. 0.54. What is the ratio of the Amount of imports(as % of merchandise imports) in Agricultural raw materials in 2002 to that in 2006?
Keep it short and to the point. 1.21. What is the ratio of the Amount of imports(as % of merchandise imports) of Food in 2002 to that in 2006?
Make the answer very short. 1.05. What is the ratio of the Amount of imports(as % of merchandise imports) of Fuel in 2002 to that in 2006?
Keep it short and to the point. 0.54. What is the ratio of the Amount of imports(as % of merchandise imports) in Agricultural raw materials in 2003 to that in 2004?
Make the answer very short. 1.03. What is the ratio of the Amount of imports(as % of merchandise imports) in Food in 2003 to that in 2004?
Provide a succinct answer. 1.06. What is the ratio of the Amount of imports(as % of merchandise imports) in Fuel in 2003 to that in 2004?
Provide a succinct answer. 0.89. What is the ratio of the Amount of imports(as % of merchandise imports) of Agricultural raw materials in 2003 to that in 2005?
Give a very brief answer. 1.1. What is the ratio of the Amount of imports(as % of merchandise imports) of Food in 2003 to that in 2005?
Your answer should be compact. 1.1. What is the ratio of the Amount of imports(as % of merchandise imports) in Fuel in 2003 to that in 2005?
Offer a very short reply. 0.69. What is the ratio of the Amount of imports(as % of merchandise imports) of Agricultural raw materials in 2003 to that in 2006?
Your response must be concise. 1.21. What is the ratio of the Amount of imports(as % of merchandise imports) of Food in 2003 to that in 2006?
Offer a terse response. 1.07. What is the ratio of the Amount of imports(as % of merchandise imports) in Fuel in 2003 to that in 2006?
Make the answer very short. 0.69. What is the ratio of the Amount of imports(as % of merchandise imports) in Agricultural raw materials in 2004 to that in 2005?
Your answer should be very brief. 1.07. What is the ratio of the Amount of imports(as % of merchandise imports) in Food in 2004 to that in 2005?
Offer a terse response. 1.03. What is the ratio of the Amount of imports(as % of merchandise imports) in Fuel in 2004 to that in 2005?
Keep it short and to the point. 0.77. What is the ratio of the Amount of imports(as % of merchandise imports) in Agricultural raw materials in 2004 to that in 2006?
Ensure brevity in your answer.  1.18. What is the ratio of the Amount of imports(as % of merchandise imports) in Fuel in 2004 to that in 2006?
Keep it short and to the point. 0.78. What is the ratio of the Amount of imports(as % of merchandise imports) in Agricultural raw materials in 2005 to that in 2006?
Offer a very short reply. 1.1. What is the ratio of the Amount of imports(as % of merchandise imports) of Food in 2005 to that in 2006?
Your response must be concise. 0.97. What is the difference between the highest and the second highest Amount of imports(as % of merchandise imports) in Agricultural raw materials?
Your answer should be compact. 0. What is the difference between the highest and the second highest Amount of imports(as % of merchandise imports) of Food?
Your answer should be very brief. 0.14. What is the difference between the highest and the second highest Amount of imports(as % of merchandise imports) in Fuel?
Offer a terse response. 0.05. What is the difference between the highest and the lowest Amount of imports(as % of merchandise imports) of Agricultural raw materials?
Provide a succinct answer. 0.23. What is the difference between the highest and the lowest Amount of imports(as % of merchandise imports) in Food?
Provide a short and direct response. 1.19. What is the difference between the highest and the lowest Amount of imports(as % of merchandise imports) of Fuel?
Your answer should be compact. 5.99. 